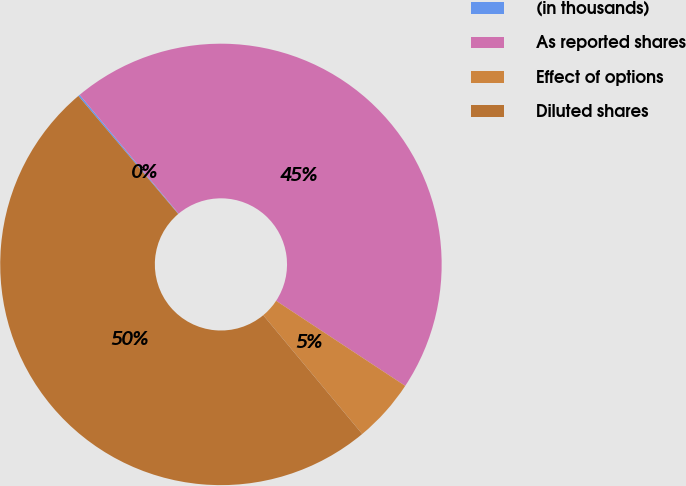Convert chart. <chart><loc_0><loc_0><loc_500><loc_500><pie_chart><fcel>(in thousands)<fcel>As reported shares<fcel>Effect of options<fcel>Diluted shares<nl><fcel>0.12%<fcel>45.33%<fcel>4.67%<fcel>49.88%<nl></chart> 